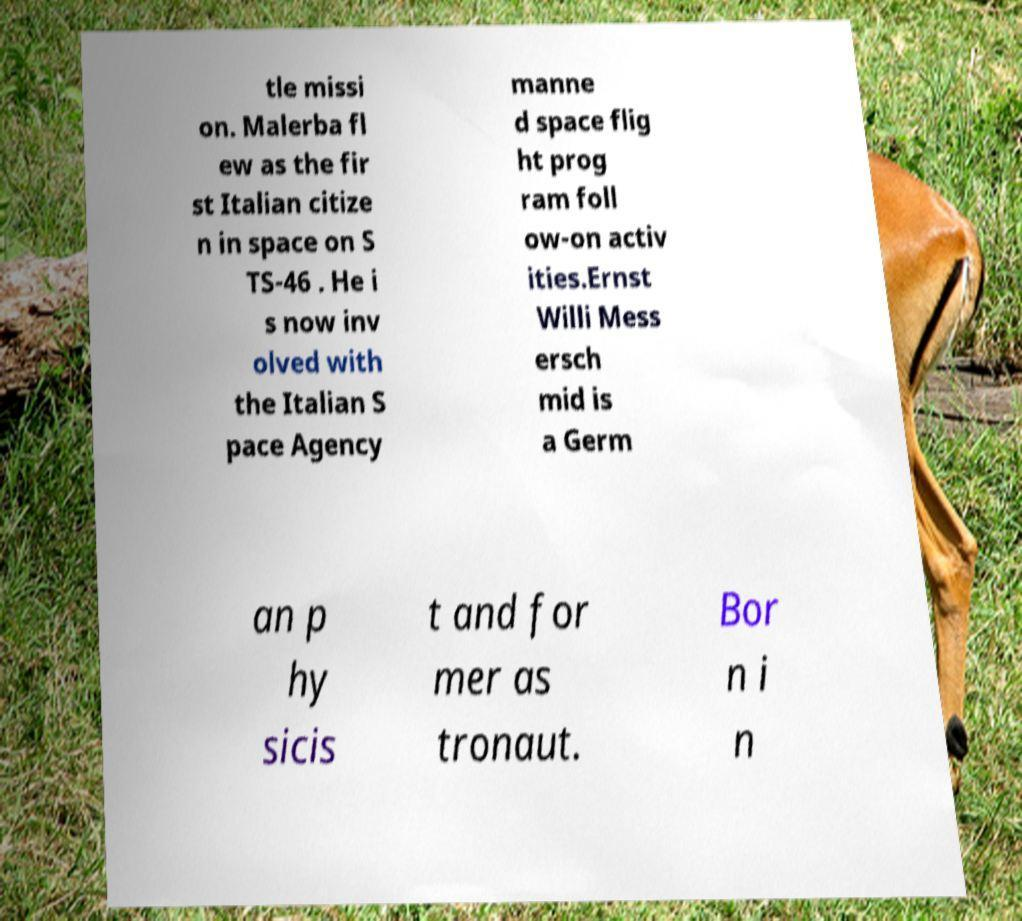Could you assist in decoding the text presented in this image and type it out clearly? tle missi on. Malerba fl ew as the fir st Italian citize n in space on S TS-46 . He i s now inv olved with the Italian S pace Agency manne d space flig ht prog ram foll ow-on activ ities.Ernst Willi Mess ersch mid is a Germ an p hy sicis t and for mer as tronaut. Bor n i n 